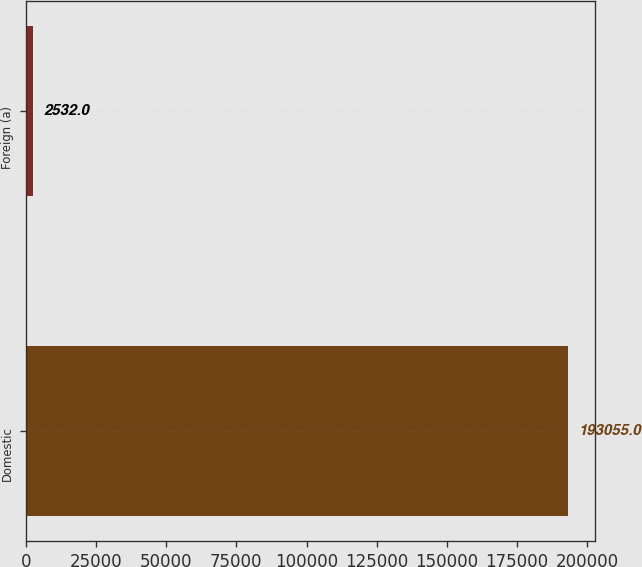Convert chart to OTSL. <chart><loc_0><loc_0><loc_500><loc_500><bar_chart><fcel>Domestic<fcel>Foreign (a)<nl><fcel>193055<fcel>2532<nl></chart> 